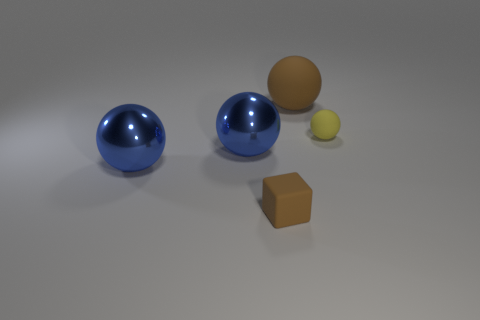Are there any rubber objects that have the same color as the tiny matte block?
Give a very brief answer. Yes. Are any blue spheres visible?
Offer a very short reply. Yes. Do the ball that is behind the small sphere and the yellow ball have the same material?
Your answer should be very brief. Yes. What size is the thing that is the same color as the large matte sphere?
Offer a very short reply. Small. What number of yellow things are the same size as the rubber block?
Give a very brief answer. 1. Are there an equal number of yellow balls that are to the left of the small yellow ball and blue metallic things?
Offer a very short reply. No. What number of small matte objects are both to the right of the brown cube and left of the large brown matte ball?
Offer a terse response. 0. What is the size of the brown cube that is made of the same material as the tiny sphere?
Keep it short and to the point. Small. How many other matte objects have the same shape as the big brown matte object?
Provide a short and direct response. 1. Is the number of things in front of the brown ball greater than the number of blocks?
Provide a short and direct response. Yes. 